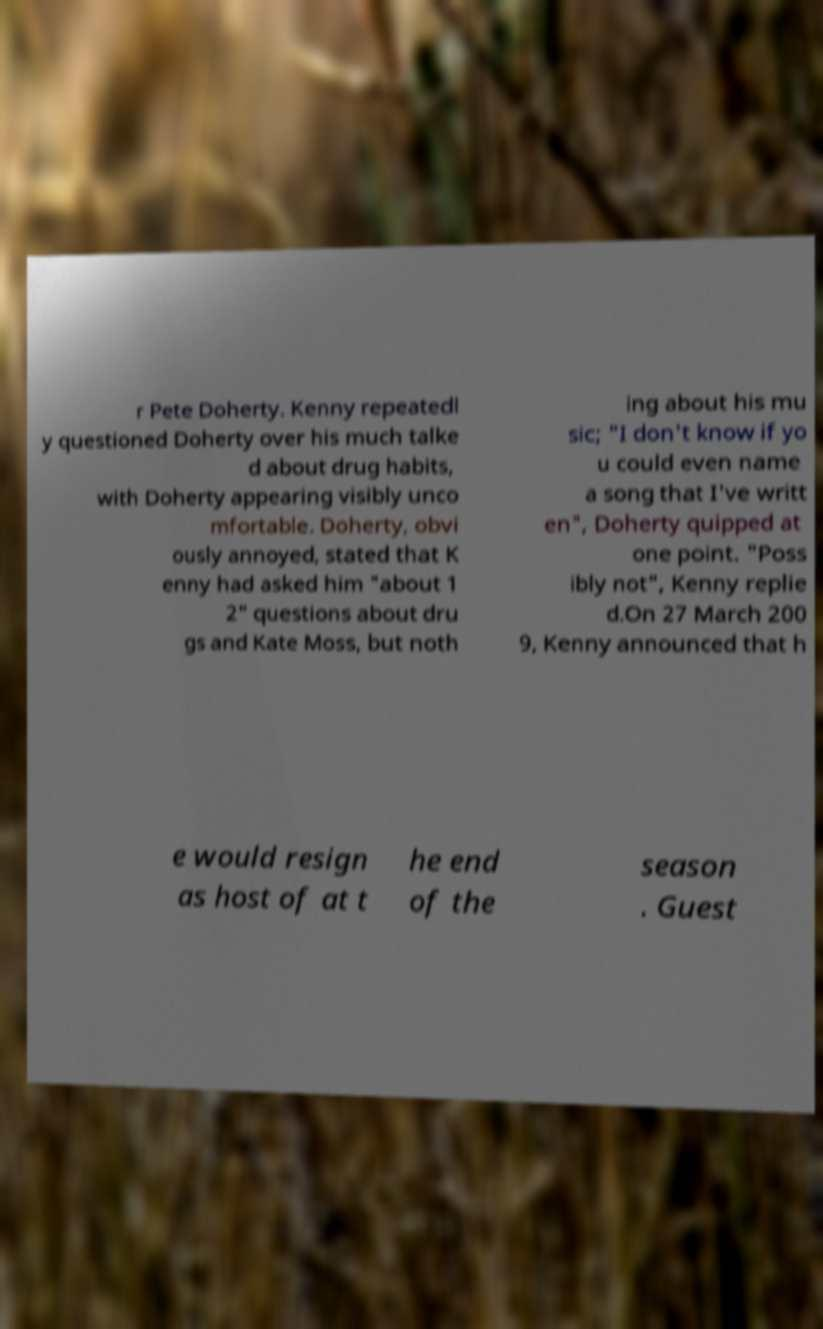Please read and relay the text visible in this image. What does it say? r Pete Doherty. Kenny repeatedl y questioned Doherty over his much talke d about drug habits, with Doherty appearing visibly unco mfortable. Doherty, obvi ously annoyed, stated that K enny had asked him "about 1 2" questions about dru gs and Kate Moss, but noth ing about his mu sic; "I don't know if yo u could even name a song that I've writt en", Doherty quipped at one point. "Poss ibly not", Kenny replie d.On 27 March 200 9, Kenny announced that h e would resign as host of at t he end of the season . Guest 